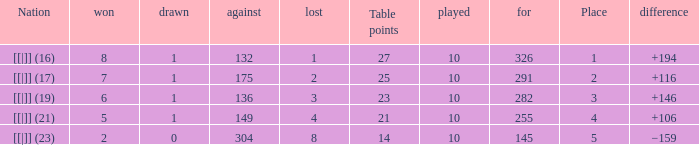 How many table points are listed for the deficit is +194?  1.0. 